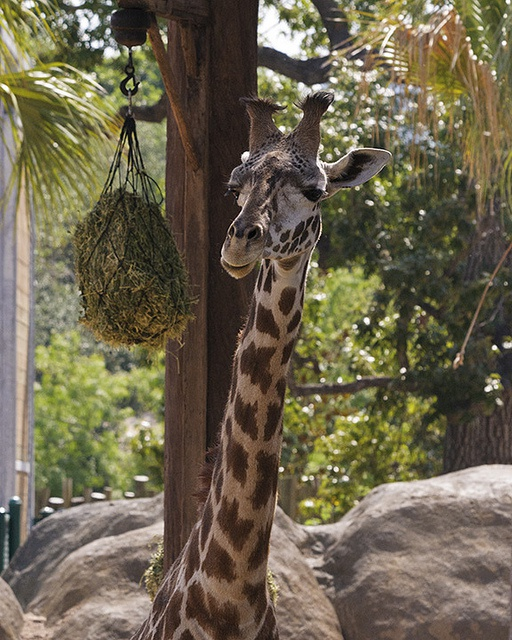Describe the objects in this image and their specific colors. I can see a giraffe in olive, black, gray, and maroon tones in this image. 